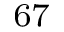<formula> <loc_0><loc_0><loc_500><loc_500>^ { 6 7 }</formula> 